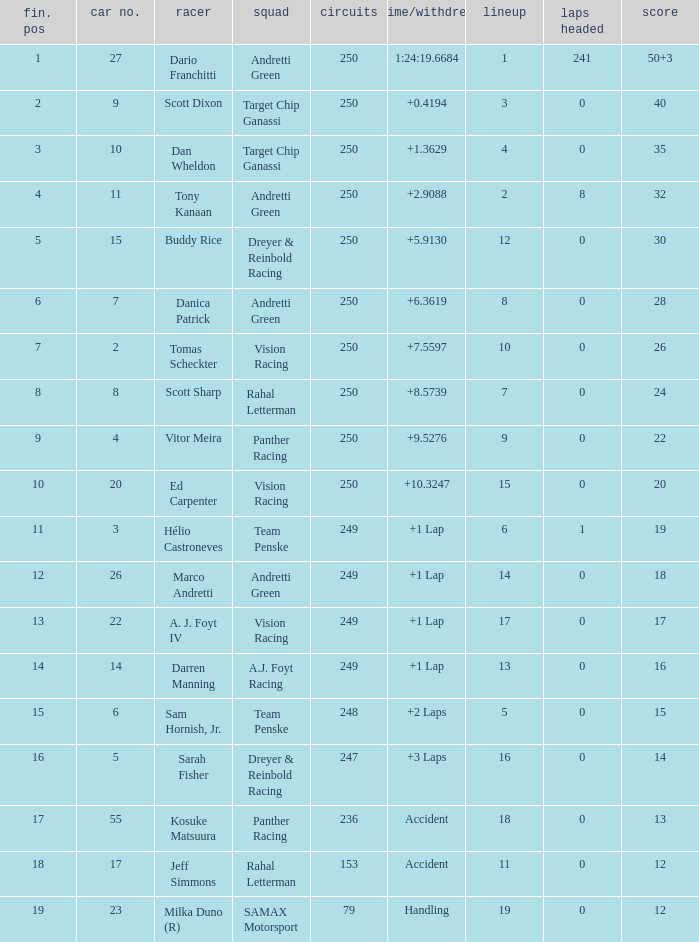Name the number of driver for fin pos of 19 1.0. 